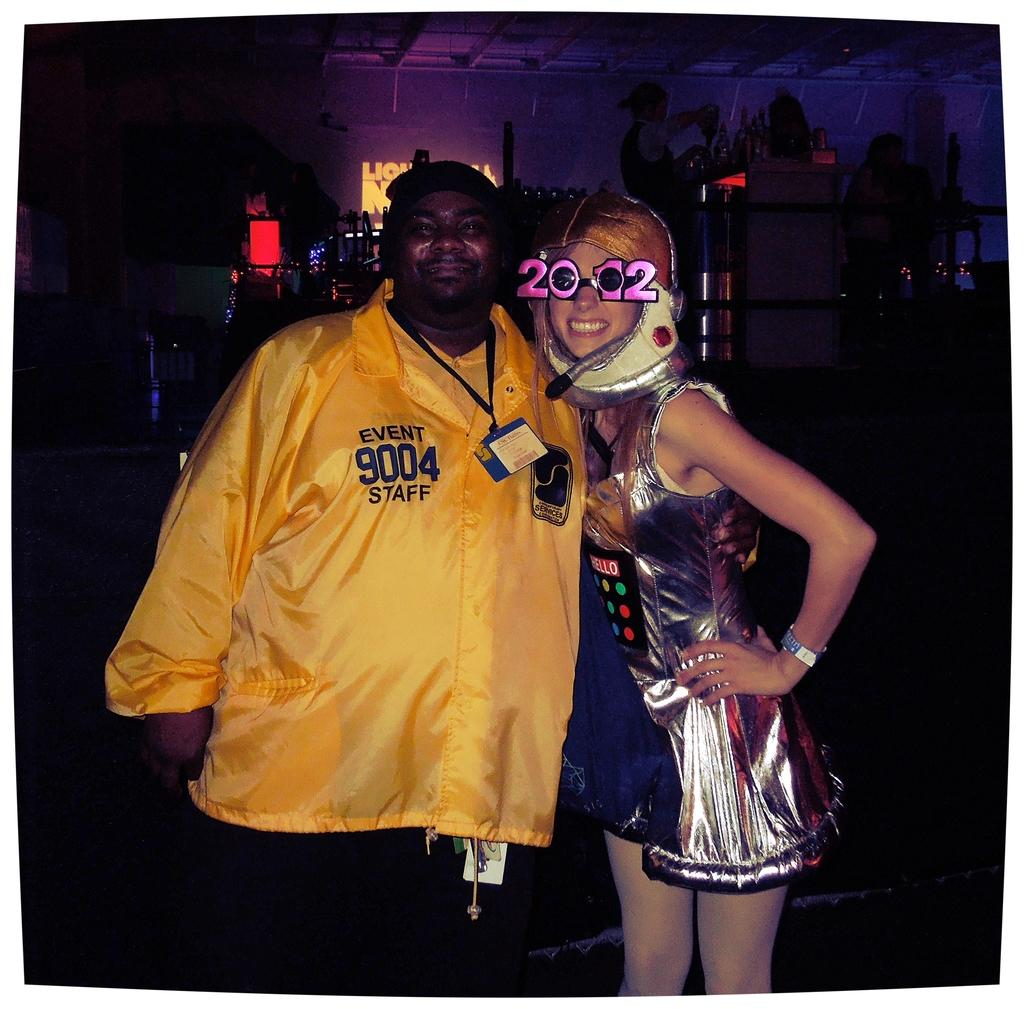What is the man in the image wearing? The man is wearing a yellow t-shirt in the image. What is the facial expression of the man in the image? The man is smiling in the image. Who is the man standing near in the image? The man is standing near a woman in the image. What is the facial expression of the woman in the image? The woman is smiling in the image. What is the woman standing on in the image? The woman is standing on the floor in the image. What can be seen in the background of the image? There are trees, hoardings, and other objects in the background of the image. What type of rings can be seen on the man's fingers in the image? There are no rings visible on the man's fingers in the image. What is the lunchroom like in the image? There is no lunchroom present in the image. 